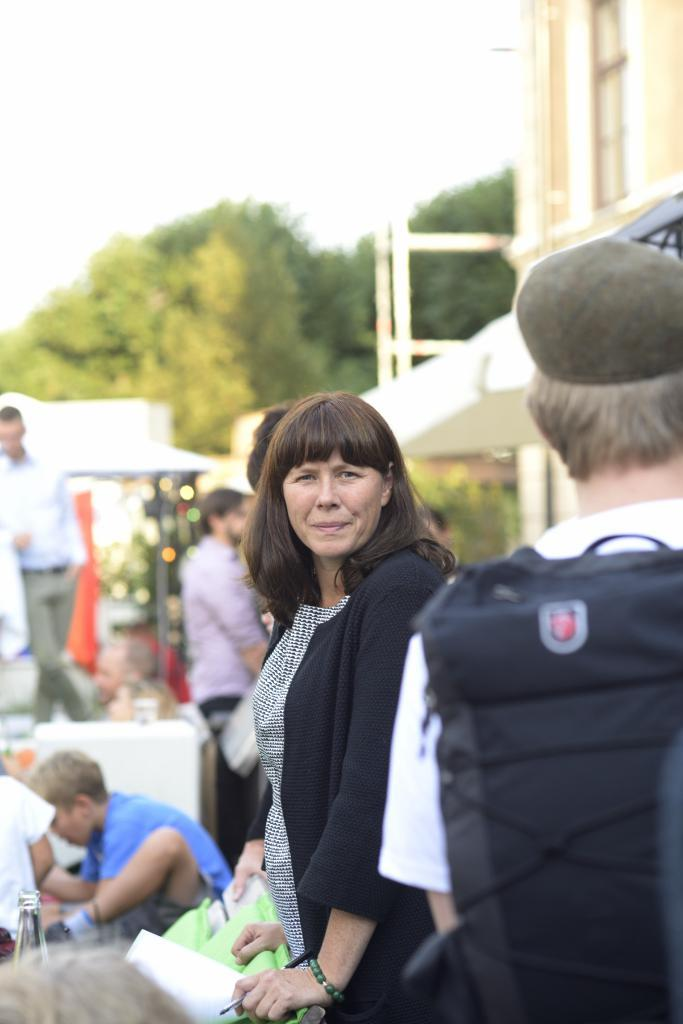What is the main subject of the image? The main subject of the image is a group of people. Can you describe the person on the right side of the image? The person on the right side of the image is wearing a cap. What can be seen in the background of the image? There is a building and trees in the background of the image. What type of adjustment is being made to the building in the image? There is no adjustment being made to the building in the image; it is a static structure in the background. 